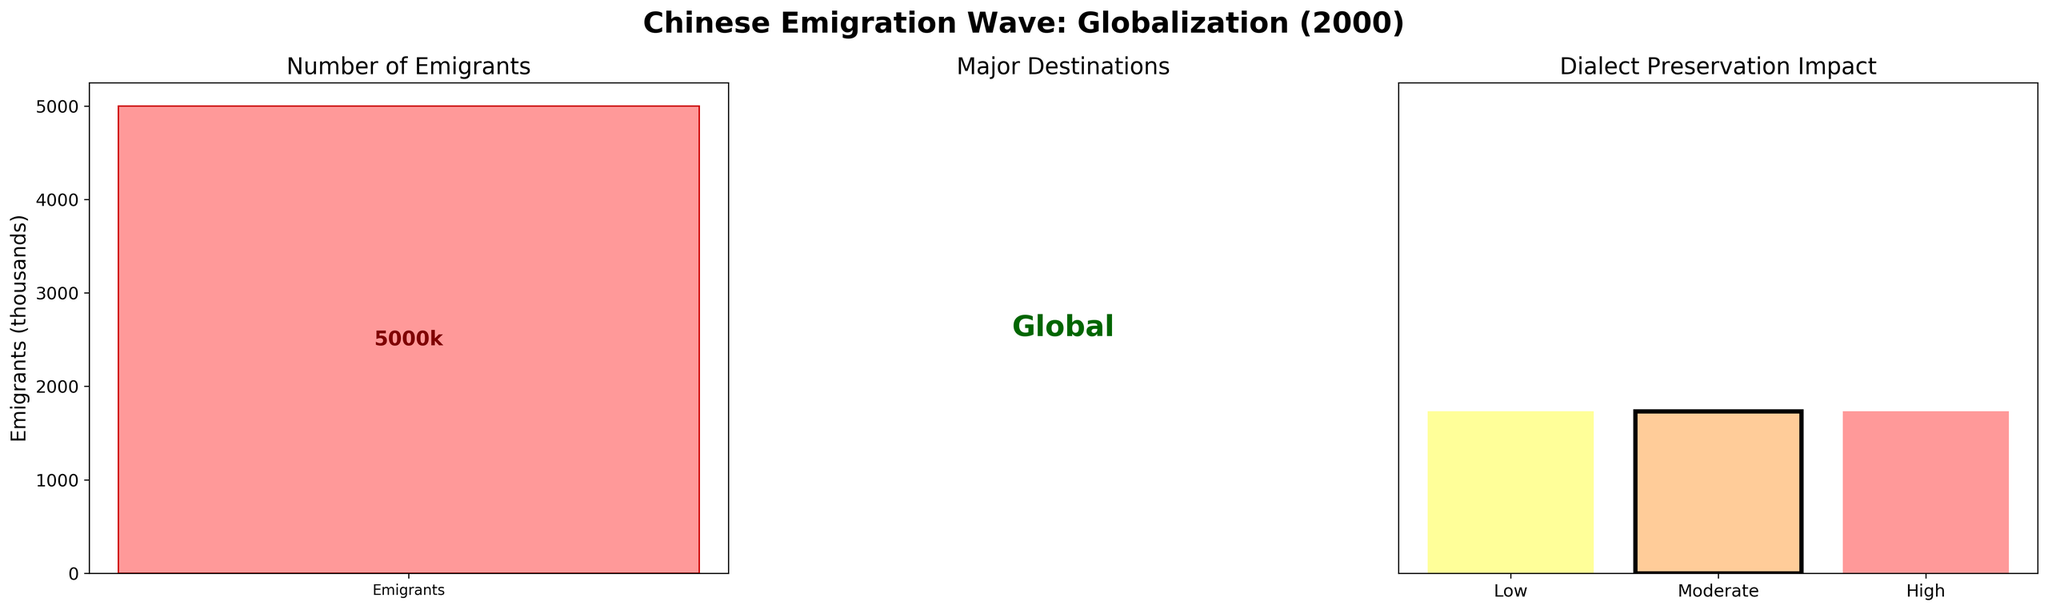What's the title of the figure? The title is displayed prominently at the top of the figure.
Answer: Chinese Emigration Wave: Globalization (2000) How many emigrants were there during the Globalization wave? The number of emigrants is indicated by the bar height and the text inside the first subplot.
Answer: 5000k What color is used to represent the Number of Emigrants? The color of the bar in the first subplot is visually observable.
Answer: Light Red (approximately) Which countries were major destinations during the Globalization wave? The major destinations are written inside the second subplot.
Answer: Global What impact level on dialect preservation does the Globalization wave have? The impact level on dialect preservation is highlighted in the third subplot with a bar and labeled text.
Answer: Moderate How does the number of emigrants during the Globalization wave compare to zero? Comparing the bar height in the first subplot to zero shows they are significantly higher.
Answer: Greater than zero Where is the Moderate impact level positioned in the Dialect Preservation Impact subplot? The Moderate impact level is centered and highlighted with a different visual edge color in the third subplot.
Answer: Centered and highlighted with a black border Which impact level has the thickest border in the Dialect Preservation Impact subplot? The visual emphasis is given to the bar with the thickest outline in the third subplot.
Answer: Moderate What are the y-axis labels in the first and third subplots? The y-axis labels are shown next to the axes; the first subplot has 'Emigrants' and the third subplot has no labels.
Answer: Emigrants, None in third What is the unique visual feature of the Moderate bar in the Dialect Preservation Impact subplot? The unique feature is the thicker black border around the Moderate impact bar.
Answer: Thicker black border 